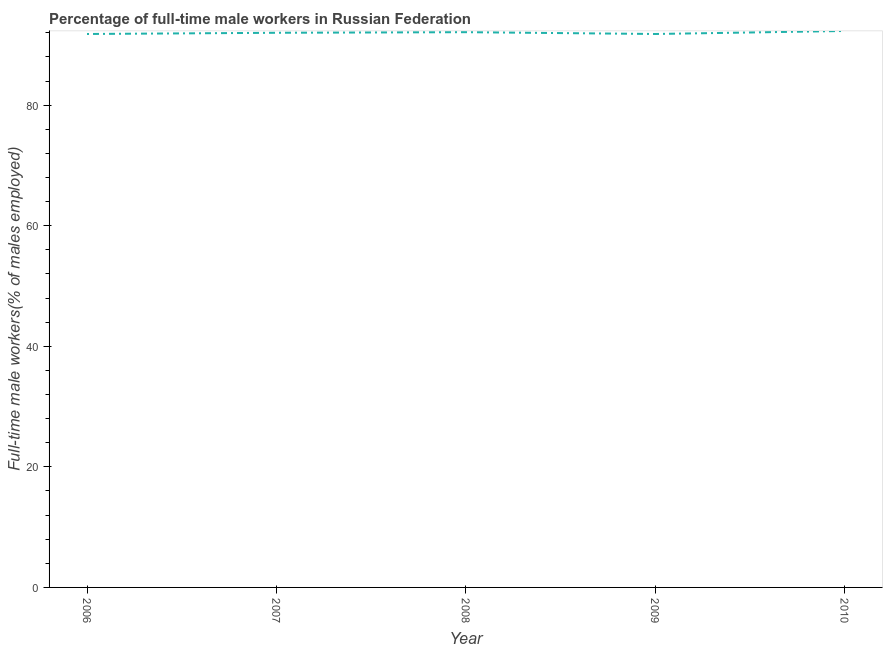What is the percentage of full-time male workers in 2008?
Your answer should be compact. 92.1. Across all years, what is the maximum percentage of full-time male workers?
Your answer should be compact. 92.3. Across all years, what is the minimum percentage of full-time male workers?
Provide a succinct answer. 91.8. What is the sum of the percentage of full-time male workers?
Your answer should be very brief. 460. What is the difference between the percentage of full-time male workers in 2006 and 2008?
Offer a terse response. -0.3. What is the average percentage of full-time male workers per year?
Offer a very short reply. 92. What is the median percentage of full-time male workers?
Your response must be concise. 92. In how many years, is the percentage of full-time male workers greater than 52 %?
Give a very brief answer. 5. What is the ratio of the percentage of full-time male workers in 2007 to that in 2008?
Offer a very short reply. 1. What is the difference between the highest and the second highest percentage of full-time male workers?
Give a very brief answer. 0.2. What is the difference between the highest and the lowest percentage of full-time male workers?
Ensure brevity in your answer.  0.5. How many years are there in the graph?
Provide a succinct answer. 5. Are the values on the major ticks of Y-axis written in scientific E-notation?
Give a very brief answer. No. Does the graph contain grids?
Keep it short and to the point. No. What is the title of the graph?
Offer a very short reply. Percentage of full-time male workers in Russian Federation. What is the label or title of the Y-axis?
Your answer should be compact. Full-time male workers(% of males employed). What is the Full-time male workers(% of males employed) in 2006?
Give a very brief answer. 91.8. What is the Full-time male workers(% of males employed) of 2007?
Your answer should be very brief. 92. What is the Full-time male workers(% of males employed) in 2008?
Your answer should be compact. 92.1. What is the Full-time male workers(% of males employed) of 2009?
Provide a succinct answer. 91.8. What is the Full-time male workers(% of males employed) in 2010?
Your answer should be very brief. 92.3. What is the difference between the Full-time male workers(% of males employed) in 2006 and 2007?
Provide a short and direct response. -0.2. What is the difference between the Full-time male workers(% of males employed) in 2006 and 2009?
Your response must be concise. 0. What is the difference between the Full-time male workers(% of males employed) in 2007 and 2010?
Provide a succinct answer. -0.3. What is the difference between the Full-time male workers(% of males employed) in 2008 and 2010?
Offer a terse response. -0.2. What is the ratio of the Full-time male workers(% of males employed) in 2006 to that in 2007?
Your response must be concise. 1. What is the ratio of the Full-time male workers(% of males employed) in 2007 to that in 2008?
Offer a very short reply. 1. What is the ratio of the Full-time male workers(% of males employed) in 2007 to that in 2009?
Give a very brief answer. 1. What is the ratio of the Full-time male workers(% of males employed) in 2007 to that in 2010?
Give a very brief answer. 1. What is the ratio of the Full-time male workers(% of males employed) in 2008 to that in 2010?
Your answer should be compact. 1. What is the ratio of the Full-time male workers(% of males employed) in 2009 to that in 2010?
Your response must be concise. 0.99. 